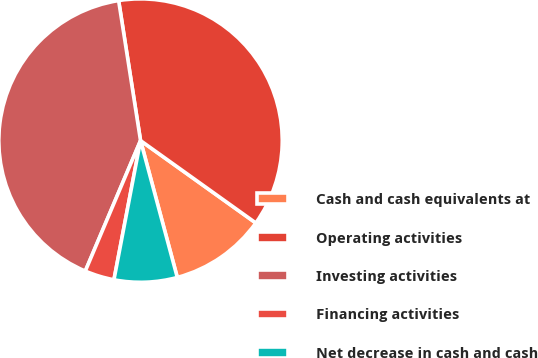Convert chart to OTSL. <chart><loc_0><loc_0><loc_500><loc_500><pie_chart><fcel>Cash and cash equivalents at<fcel>Operating activities<fcel>Investing activities<fcel>Financing activities<fcel>Net decrease in cash and cash<nl><fcel>10.95%<fcel>37.35%<fcel>41.16%<fcel>3.37%<fcel>7.18%<nl></chart> 